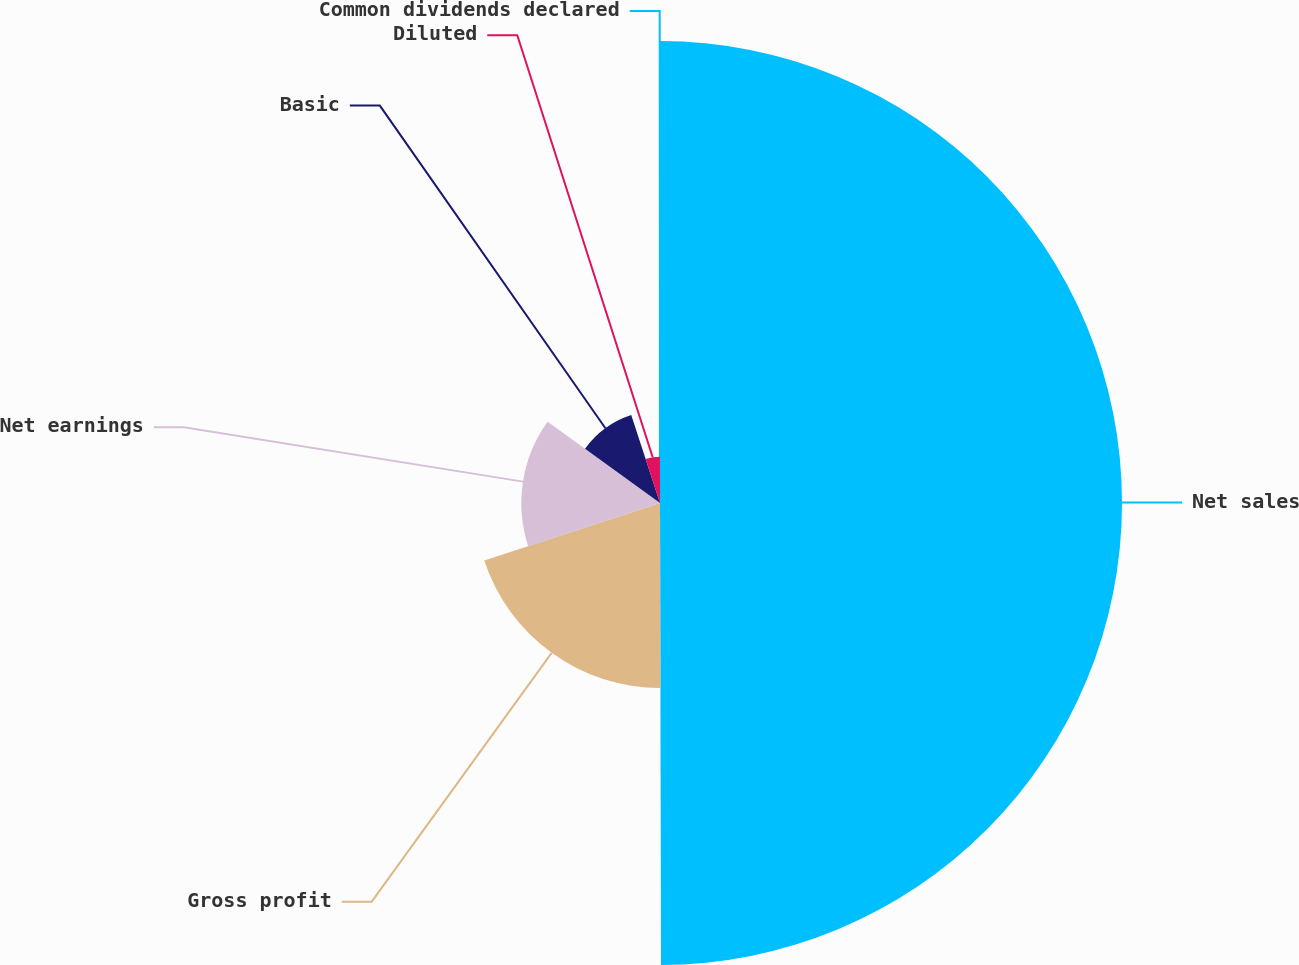<chart> <loc_0><loc_0><loc_500><loc_500><pie_chart><fcel>Net sales<fcel>Gross profit<fcel>Net earnings<fcel>Basic<fcel>Diluted<fcel>Common dividends declared<nl><fcel>49.97%<fcel>20.0%<fcel>15.0%<fcel>10.01%<fcel>5.01%<fcel>0.02%<nl></chart> 